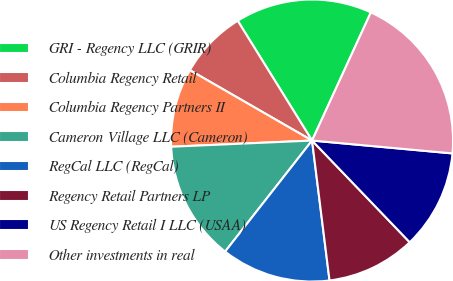Convert chart. <chart><loc_0><loc_0><loc_500><loc_500><pie_chart><fcel>GRI - Regency LLC (GRIR)<fcel>Columbia Regency Retail<fcel>Columbia Regency Partners II<fcel>Cameron Village LLC (Cameron)<fcel>RegCal LLC (RegCal)<fcel>Regency Retail Partners LP<fcel>US Regency Retail I LLC (USAA)<fcel>Other investments in real<nl><fcel>15.69%<fcel>7.84%<fcel>9.02%<fcel>13.73%<fcel>12.55%<fcel>10.2%<fcel>11.37%<fcel>19.61%<nl></chart> 